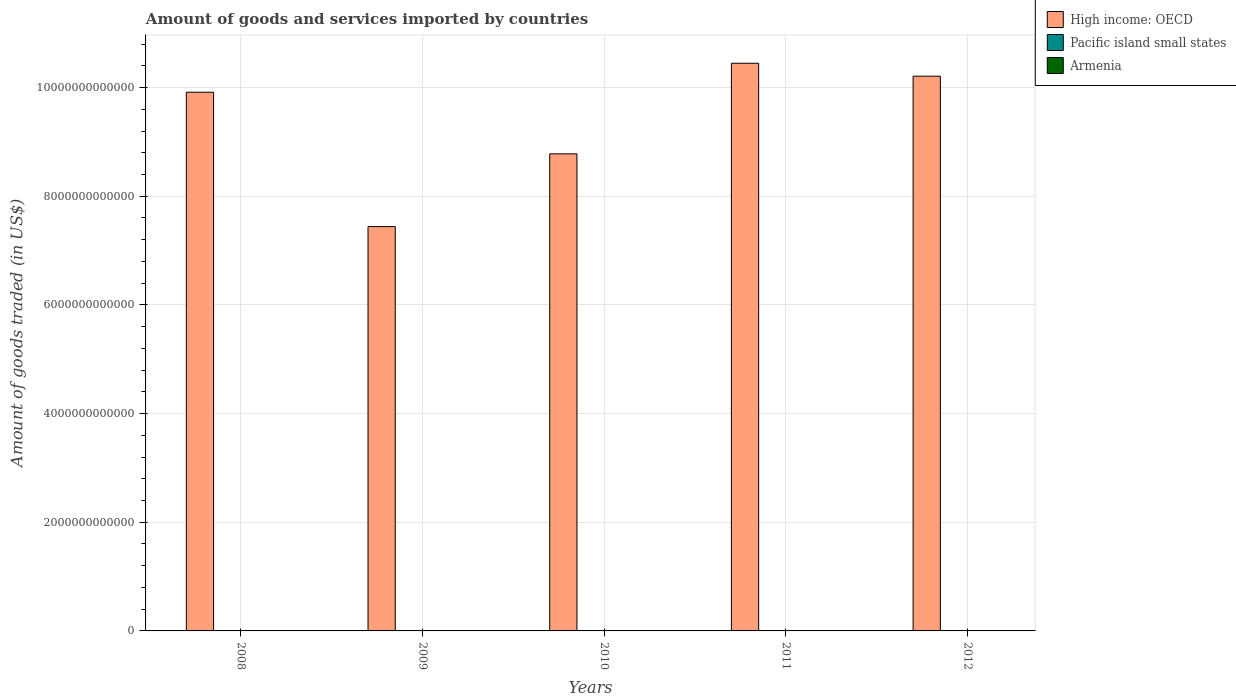Are the number of bars per tick equal to the number of legend labels?
Provide a succinct answer. Yes. How many bars are there on the 4th tick from the left?
Offer a very short reply. 3. How many bars are there on the 2nd tick from the right?
Offer a very short reply. 3. In how many cases, is the number of bars for a given year not equal to the number of legend labels?
Keep it short and to the point. 0. What is the total amount of goods and services imported in Pacific island small states in 2012?
Provide a short and direct response. 3.68e+09. Across all years, what is the maximum total amount of goods and services imported in High income: OECD?
Provide a succinct answer. 1.04e+13. Across all years, what is the minimum total amount of goods and services imported in Pacific island small states?
Ensure brevity in your answer.  2.46e+09. In which year was the total amount of goods and services imported in Armenia maximum?
Provide a succinct answer. 2008. In which year was the total amount of goods and services imported in High income: OECD minimum?
Provide a short and direct response. 2009. What is the total total amount of goods and services imported in High income: OECD in the graph?
Keep it short and to the point. 4.68e+13. What is the difference between the total amount of goods and services imported in Pacific island small states in 2008 and that in 2012?
Give a very brief answer. -1.93e+08. What is the difference between the total amount of goods and services imported in Armenia in 2011 and the total amount of goods and services imported in High income: OECD in 2008?
Your answer should be very brief. -9.91e+12. What is the average total amount of goods and services imported in Pacific island small states per year?
Your answer should be very brief. 3.26e+09. In the year 2011, what is the difference between the total amount of goods and services imported in Pacific island small states and total amount of goods and services imported in High income: OECD?
Offer a terse response. -1.04e+13. What is the ratio of the total amount of goods and services imported in High income: OECD in 2010 to that in 2011?
Your response must be concise. 0.84. What is the difference between the highest and the second highest total amount of goods and services imported in Armenia?
Your answer should be very brief. 2.95e+08. What is the difference between the highest and the lowest total amount of goods and services imported in High income: OECD?
Ensure brevity in your answer.  3.01e+12. In how many years, is the total amount of goods and services imported in Armenia greater than the average total amount of goods and services imported in Armenia taken over all years?
Ensure brevity in your answer.  3. What does the 2nd bar from the left in 2011 represents?
Offer a very short reply. Pacific island small states. What does the 3rd bar from the right in 2008 represents?
Offer a terse response. High income: OECD. How many bars are there?
Offer a very short reply. 15. What is the difference between two consecutive major ticks on the Y-axis?
Offer a very short reply. 2.00e+12. Does the graph contain any zero values?
Provide a short and direct response. No. Does the graph contain grids?
Your answer should be very brief. Yes. How are the legend labels stacked?
Keep it short and to the point. Vertical. What is the title of the graph?
Your answer should be very brief. Amount of goods and services imported by countries. What is the label or title of the Y-axis?
Your answer should be compact. Amount of goods traded (in US$). What is the Amount of goods traded (in US$) in High income: OECD in 2008?
Your answer should be very brief. 9.91e+12. What is the Amount of goods traded (in US$) of Pacific island small states in 2008?
Keep it short and to the point. 3.49e+09. What is the Amount of goods traded (in US$) of Armenia in 2008?
Provide a succinct answer. 3.92e+09. What is the Amount of goods traded (in US$) of High income: OECD in 2009?
Make the answer very short. 7.44e+12. What is the Amount of goods traded (in US$) in Pacific island small states in 2009?
Offer a terse response. 2.46e+09. What is the Amount of goods traded (in US$) of Armenia in 2009?
Provide a short and direct response. 2.86e+09. What is the Amount of goods traded (in US$) in High income: OECD in 2010?
Ensure brevity in your answer.  8.78e+12. What is the Amount of goods traded (in US$) of Pacific island small states in 2010?
Offer a terse response. 3.06e+09. What is the Amount of goods traded (in US$) of Armenia in 2010?
Make the answer very short. 3.26e+09. What is the Amount of goods traded (in US$) of High income: OECD in 2011?
Provide a short and direct response. 1.04e+13. What is the Amount of goods traded (in US$) of Pacific island small states in 2011?
Provide a succinct answer. 3.61e+09. What is the Amount of goods traded (in US$) in Armenia in 2011?
Make the answer very short. 3.54e+09. What is the Amount of goods traded (in US$) in High income: OECD in 2012?
Provide a succinct answer. 1.02e+13. What is the Amount of goods traded (in US$) in Pacific island small states in 2012?
Ensure brevity in your answer.  3.68e+09. What is the Amount of goods traded (in US$) in Armenia in 2012?
Your answer should be compact. 3.63e+09. Across all years, what is the maximum Amount of goods traded (in US$) of High income: OECD?
Provide a succinct answer. 1.04e+13. Across all years, what is the maximum Amount of goods traded (in US$) in Pacific island small states?
Give a very brief answer. 3.68e+09. Across all years, what is the maximum Amount of goods traded (in US$) in Armenia?
Your response must be concise. 3.92e+09. Across all years, what is the minimum Amount of goods traded (in US$) of High income: OECD?
Ensure brevity in your answer.  7.44e+12. Across all years, what is the minimum Amount of goods traded (in US$) of Pacific island small states?
Offer a very short reply. 2.46e+09. Across all years, what is the minimum Amount of goods traded (in US$) of Armenia?
Provide a succinct answer. 2.86e+09. What is the total Amount of goods traded (in US$) in High income: OECD in the graph?
Provide a succinct answer. 4.68e+13. What is the total Amount of goods traded (in US$) in Pacific island small states in the graph?
Keep it short and to the point. 1.63e+1. What is the total Amount of goods traded (in US$) in Armenia in the graph?
Give a very brief answer. 1.72e+1. What is the difference between the Amount of goods traded (in US$) of High income: OECD in 2008 and that in 2009?
Keep it short and to the point. 2.47e+12. What is the difference between the Amount of goods traded (in US$) in Pacific island small states in 2008 and that in 2009?
Give a very brief answer. 1.02e+09. What is the difference between the Amount of goods traded (in US$) of Armenia in 2008 and that in 2009?
Offer a terse response. 1.06e+09. What is the difference between the Amount of goods traded (in US$) of High income: OECD in 2008 and that in 2010?
Your response must be concise. 1.13e+12. What is the difference between the Amount of goods traded (in US$) of Pacific island small states in 2008 and that in 2010?
Offer a very short reply. 4.30e+08. What is the difference between the Amount of goods traded (in US$) of Armenia in 2008 and that in 2010?
Offer a terse response. 6.59e+08. What is the difference between the Amount of goods traded (in US$) of High income: OECD in 2008 and that in 2011?
Give a very brief answer. -5.33e+11. What is the difference between the Amount of goods traded (in US$) of Pacific island small states in 2008 and that in 2011?
Provide a short and direct response. -1.23e+08. What is the difference between the Amount of goods traded (in US$) in Armenia in 2008 and that in 2011?
Your answer should be very brief. 3.81e+08. What is the difference between the Amount of goods traded (in US$) in High income: OECD in 2008 and that in 2012?
Give a very brief answer. -2.95e+11. What is the difference between the Amount of goods traded (in US$) of Pacific island small states in 2008 and that in 2012?
Ensure brevity in your answer.  -1.93e+08. What is the difference between the Amount of goods traded (in US$) of Armenia in 2008 and that in 2012?
Keep it short and to the point. 2.95e+08. What is the difference between the Amount of goods traded (in US$) of High income: OECD in 2009 and that in 2010?
Ensure brevity in your answer.  -1.34e+12. What is the difference between the Amount of goods traded (in US$) of Pacific island small states in 2009 and that in 2010?
Provide a succinct answer. -5.94e+08. What is the difference between the Amount of goods traded (in US$) of Armenia in 2009 and that in 2010?
Your answer should be very brief. -4.00e+08. What is the difference between the Amount of goods traded (in US$) in High income: OECD in 2009 and that in 2011?
Your answer should be very brief. -3.01e+12. What is the difference between the Amount of goods traded (in US$) of Pacific island small states in 2009 and that in 2011?
Offer a very short reply. -1.15e+09. What is the difference between the Amount of goods traded (in US$) of Armenia in 2009 and that in 2011?
Provide a succinct answer. -6.78e+08. What is the difference between the Amount of goods traded (in US$) in High income: OECD in 2009 and that in 2012?
Ensure brevity in your answer.  -2.77e+12. What is the difference between the Amount of goods traded (in US$) in Pacific island small states in 2009 and that in 2012?
Offer a terse response. -1.22e+09. What is the difference between the Amount of goods traded (in US$) of Armenia in 2009 and that in 2012?
Offer a terse response. -7.64e+08. What is the difference between the Amount of goods traded (in US$) of High income: OECD in 2010 and that in 2011?
Your answer should be compact. -1.67e+12. What is the difference between the Amount of goods traded (in US$) of Pacific island small states in 2010 and that in 2011?
Ensure brevity in your answer.  -5.54e+08. What is the difference between the Amount of goods traded (in US$) of Armenia in 2010 and that in 2011?
Provide a short and direct response. -2.78e+08. What is the difference between the Amount of goods traded (in US$) in High income: OECD in 2010 and that in 2012?
Give a very brief answer. -1.43e+12. What is the difference between the Amount of goods traded (in US$) of Pacific island small states in 2010 and that in 2012?
Offer a very short reply. -6.24e+08. What is the difference between the Amount of goods traded (in US$) of Armenia in 2010 and that in 2012?
Give a very brief answer. -3.64e+08. What is the difference between the Amount of goods traded (in US$) in High income: OECD in 2011 and that in 2012?
Provide a succinct answer. 2.38e+11. What is the difference between the Amount of goods traded (in US$) in Pacific island small states in 2011 and that in 2012?
Provide a short and direct response. -6.97e+07. What is the difference between the Amount of goods traded (in US$) in Armenia in 2011 and that in 2012?
Provide a short and direct response. -8.62e+07. What is the difference between the Amount of goods traded (in US$) of High income: OECD in 2008 and the Amount of goods traded (in US$) of Pacific island small states in 2009?
Offer a terse response. 9.91e+12. What is the difference between the Amount of goods traded (in US$) in High income: OECD in 2008 and the Amount of goods traded (in US$) in Armenia in 2009?
Make the answer very short. 9.91e+12. What is the difference between the Amount of goods traded (in US$) of Pacific island small states in 2008 and the Amount of goods traded (in US$) of Armenia in 2009?
Keep it short and to the point. 6.25e+08. What is the difference between the Amount of goods traded (in US$) of High income: OECD in 2008 and the Amount of goods traded (in US$) of Pacific island small states in 2010?
Provide a succinct answer. 9.91e+12. What is the difference between the Amount of goods traded (in US$) in High income: OECD in 2008 and the Amount of goods traded (in US$) in Armenia in 2010?
Ensure brevity in your answer.  9.91e+12. What is the difference between the Amount of goods traded (in US$) in Pacific island small states in 2008 and the Amount of goods traded (in US$) in Armenia in 2010?
Offer a very short reply. 2.26e+08. What is the difference between the Amount of goods traded (in US$) of High income: OECD in 2008 and the Amount of goods traded (in US$) of Pacific island small states in 2011?
Offer a very short reply. 9.91e+12. What is the difference between the Amount of goods traded (in US$) in High income: OECD in 2008 and the Amount of goods traded (in US$) in Armenia in 2011?
Keep it short and to the point. 9.91e+12. What is the difference between the Amount of goods traded (in US$) in Pacific island small states in 2008 and the Amount of goods traded (in US$) in Armenia in 2011?
Your answer should be compact. -5.24e+07. What is the difference between the Amount of goods traded (in US$) of High income: OECD in 2008 and the Amount of goods traded (in US$) of Pacific island small states in 2012?
Provide a succinct answer. 9.91e+12. What is the difference between the Amount of goods traded (in US$) of High income: OECD in 2008 and the Amount of goods traded (in US$) of Armenia in 2012?
Your answer should be compact. 9.91e+12. What is the difference between the Amount of goods traded (in US$) of Pacific island small states in 2008 and the Amount of goods traded (in US$) of Armenia in 2012?
Make the answer very short. -1.39e+08. What is the difference between the Amount of goods traded (in US$) in High income: OECD in 2009 and the Amount of goods traded (in US$) in Pacific island small states in 2010?
Offer a very short reply. 7.44e+12. What is the difference between the Amount of goods traded (in US$) in High income: OECD in 2009 and the Amount of goods traded (in US$) in Armenia in 2010?
Ensure brevity in your answer.  7.44e+12. What is the difference between the Amount of goods traded (in US$) in Pacific island small states in 2009 and the Amount of goods traded (in US$) in Armenia in 2010?
Offer a terse response. -7.99e+08. What is the difference between the Amount of goods traded (in US$) of High income: OECD in 2009 and the Amount of goods traded (in US$) of Pacific island small states in 2011?
Your answer should be compact. 7.44e+12. What is the difference between the Amount of goods traded (in US$) in High income: OECD in 2009 and the Amount of goods traded (in US$) in Armenia in 2011?
Give a very brief answer. 7.44e+12. What is the difference between the Amount of goods traded (in US$) of Pacific island small states in 2009 and the Amount of goods traded (in US$) of Armenia in 2011?
Your answer should be very brief. -1.08e+09. What is the difference between the Amount of goods traded (in US$) in High income: OECD in 2009 and the Amount of goods traded (in US$) in Pacific island small states in 2012?
Make the answer very short. 7.44e+12. What is the difference between the Amount of goods traded (in US$) of High income: OECD in 2009 and the Amount of goods traded (in US$) of Armenia in 2012?
Provide a short and direct response. 7.44e+12. What is the difference between the Amount of goods traded (in US$) in Pacific island small states in 2009 and the Amount of goods traded (in US$) in Armenia in 2012?
Your answer should be compact. -1.16e+09. What is the difference between the Amount of goods traded (in US$) in High income: OECD in 2010 and the Amount of goods traded (in US$) in Pacific island small states in 2011?
Keep it short and to the point. 8.78e+12. What is the difference between the Amount of goods traded (in US$) in High income: OECD in 2010 and the Amount of goods traded (in US$) in Armenia in 2011?
Give a very brief answer. 8.78e+12. What is the difference between the Amount of goods traded (in US$) in Pacific island small states in 2010 and the Amount of goods traded (in US$) in Armenia in 2011?
Provide a short and direct response. -4.83e+08. What is the difference between the Amount of goods traded (in US$) in High income: OECD in 2010 and the Amount of goods traded (in US$) in Pacific island small states in 2012?
Provide a succinct answer. 8.78e+12. What is the difference between the Amount of goods traded (in US$) of High income: OECD in 2010 and the Amount of goods traded (in US$) of Armenia in 2012?
Offer a terse response. 8.78e+12. What is the difference between the Amount of goods traded (in US$) in Pacific island small states in 2010 and the Amount of goods traded (in US$) in Armenia in 2012?
Ensure brevity in your answer.  -5.69e+08. What is the difference between the Amount of goods traded (in US$) of High income: OECD in 2011 and the Amount of goods traded (in US$) of Pacific island small states in 2012?
Give a very brief answer. 1.04e+13. What is the difference between the Amount of goods traded (in US$) of High income: OECD in 2011 and the Amount of goods traded (in US$) of Armenia in 2012?
Provide a succinct answer. 1.04e+13. What is the difference between the Amount of goods traded (in US$) in Pacific island small states in 2011 and the Amount of goods traded (in US$) in Armenia in 2012?
Provide a short and direct response. -1.52e+07. What is the average Amount of goods traded (in US$) of High income: OECD per year?
Give a very brief answer. 9.36e+12. What is the average Amount of goods traded (in US$) of Pacific island small states per year?
Ensure brevity in your answer.  3.26e+09. What is the average Amount of goods traded (in US$) in Armenia per year?
Keep it short and to the point. 3.44e+09. In the year 2008, what is the difference between the Amount of goods traded (in US$) of High income: OECD and Amount of goods traded (in US$) of Pacific island small states?
Ensure brevity in your answer.  9.91e+12. In the year 2008, what is the difference between the Amount of goods traded (in US$) in High income: OECD and Amount of goods traded (in US$) in Armenia?
Offer a terse response. 9.91e+12. In the year 2008, what is the difference between the Amount of goods traded (in US$) in Pacific island small states and Amount of goods traded (in US$) in Armenia?
Your answer should be very brief. -4.34e+08. In the year 2009, what is the difference between the Amount of goods traded (in US$) in High income: OECD and Amount of goods traded (in US$) in Pacific island small states?
Your answer should be compact. 7.44e+12. In the year 2009, what is the difference between the Amount of goods traded (in US$) of High income: OECD and Amount of goods traded (in US$) of Armenia?
Your answer should be very brief. 7.44e+12. In the year 2009, what is the difference between the Amount of goods traded (in US$) of Pacific island small states and Amount of goods traded (in US$) of Armenia?
Offer a terse response. -3.99e+08. In the year 2010, what is the difference between the Amount of goods traded (in US$) of High income: OECD and Amount of goods traded (in US$) of Pacific island small states?
Offer a terse response. 8.78e+12. In the year 2010, what is the difference between the Amount of goods traded (in US$) in High income: OECD and Amount of goods traded (in US$) in Armenia?
Provide a succinct answer. 8.78e+12. In the year 2010, what is the difference between the Amount of goods traded (in US$) of Pacific island small states and Amount of goods traded (in US$) of Armenia?
Provide a succinct answer. -2.05e+08. In the year 2011, what is the difference between the Amount of goods traded (in US$) in High income: OECD and Amount of goods traded (in US$) in Pacific island small states?
Provide a short and direct response. 1.04e+13. In the year 2011, what is the difference between the Amount of goods traded (in US$) of High income: OECD and Amount of goods traded (in US$) of Armenia?
Provide a succinct answer. 1.04e+13. In the year 2011, what is the difference between the Amount of goods traded (in US$) of Pacific island small states and Amount of goods traded (in US$) of Armenia?
Offer a terse response. 7.10e+07. In the year 2012, what is the difference between the Amount of goods traded (in US$) of High income: OECD and Amount of goods traded (in US$) of Pacific island small states?
Your response must be concise. 1.02e+13. In the year 2012, what is the difference between the Amount of goods traded (in US$) of High income: OECD and Amount of goods traded (in US$) of Armenia?
Your answer should be very brief. 1.02e+13. In the year 2012, what is the difference between the Amount of goods traded (in US$) of Pacific island small states and Amount of goods traded (in US$) of Armenia?
Offer a terse response. 5.44e+07. What is the ratio of the Amount of goods traded (in US$) in High income: OECD in 2008 to that in 2009?
Provide a succinct answer. 1.33. What is the ratio of the Amount of goods traded (in US$) in Pacific island small states in 2008 to that in 2009?
Make the answer very short. 1.42. What is the ratio of the Amount of goods traded (in US$) in Armenia in 2008 to that in 2009?
Make the answer very short. 1.37. What is the ratio of the Amount of goods traded (in US$) of High income: OECD in 2008 to that in 2010?
Your response must be concise. 1.13. What is the ratio of the Amount of goods traded (in US$) in Pacific island small states in 2008 to that in 2010?
Provide a short and direct response. 1.14. What is the ratio of the Amount of goods traded (in US$) in Armenia in 2008 to that in 2010?
Keep it short and to the point. 1.2. What is the ratio of the Amount of goods traded (in US$) in High income: OECD in 2008 to that in 2011?
Your answer should be compact. 0.95. What is the ratio of the Amount of goods traded (in US$) in Pacific island small states in 2008 to that in 2011?
Your response must be concise. 0.97. What is the ratio of the Amount of goods traded (in US$) in Armenia in 2008 to that in 2011?
Provide a short and direct response. 1.11. What is the ratio of the Amount of goods traded (in US$) in High income: OECD in 2008 to that in 2012?
Offer a very short reply. 0.97. What is the ratio of the Amount of goods traded (in US$) of Pacific island small states in 2008 to that in 2012?
Offer a terse response. 0.95. What is the ratio of the Amount of goods traded (in US$) in Armenia in 2008 to that in 2012?
Keep it short and to the point. 1.08. What is the ratio of the Amount of goods traded (in US$) in High income: OECD in 2009 to that in 2010?
Provide a succinct answer. 0.85. What is the ratio of the Amount of goods traded (in US$) of Pacific island small states in 2009 to that in 2010?
Provide a succinct answer. 0.81. What is the ratio of the Amount of goods traded (in US$) of Armenia in 2009 to that in 2010?
Provide a short and direct response. 0.88. What is the ratio of the Amount of goods traded (in US$) in High income: OECD in 2009 to that in 2011?
Provide a short and direct response. 0.71. What is the ratio of the Amount of goods traded (in US$) in Pacific island small states in 2009 to that in 2011?
Give a very brief answer. 0.68. What is the ratio of the Amount of goods traded (in US$) of Armenia in 2009 to that in 2011?
Your answer should be compact. 0.81. What is the ratio of the Amount of goods traded (in US$) in High income: OECD in 2009 to that in 2012?
Your answer should be compact. 0.73. What is the ratio of the Amount of goods traded (in US$) in Pacific island small states in 2009 to that in 2012?
Keep it short and to the point. 0.67. What is the ratio of the Amount of goods traded (in US$) in Armenia in 2009 to that in 2012?
Offer a very short reply. 0.79. What is the ratio of the Amount of goods traded (in US$) of High income: OECD in 2010 to that in 2011?
Give a very brief answer. 0.84. What is the ratio of the Amount of goods traded (in US$) of Pacific island small states in 2010 to that in 2011?
Give a very brief answer. 0.85. What is the ratio of the Amount of goods traded (in US$) in Armenia in 2010 to that in 2011?
Provide a short and direct response. 0.92. What is the ratio of the Amount of goods traded (in US$) in High income: OECD in 2010 to that in 2012?
Give a very brief answer. 0.86. What is the ratio of the Amount of goods traded (in US$) in Pacific island small states in 2010 to that in 2012?
Ensure brevity in your answer.  0.83. What is the ratio of the Amount of goods traded (in US$) in Armenia in 2010 to that in 2012?
Provide a succinct answer. 0.9. What is the ratio of the Amount of goods traded (in US$) in High income: OECD in 2011 to that in 2012?
Give a very brief answer. 1.02. What is the ratio of the Amount of goods traded (in US$) in Pacific island small states in 2011 to that in 2012?
Give a very brief answer. 0.98. What is the ratio of the Amount of goods traded (in US$) in Armenia in 2011 to that in 2012?
Provide a short and direct response. 0.98. What is the difference between the highest and the second highest Amount of goods traded (in US$) in High income: OECD?
Make the answer very short. 2.38e+11. What is the difference between the highest and the second highest Amount of goods traded (in US$) of Pacific island small states?
Offer a very short reply. 6.97e+07. What is the difference between the highest and the second highest Amount of goods traded (in US$) in Armenia?
Offer a terse response. 2.95e+08. What is the difference between the highest and the lowest Amount of goods traded (in US$) in High income: OECD?
Your answer should be compact. 3.01e+12. What is the difference between the highest and the lowest Amount of goods traded (in US$) in Pacific island small states?
Offer a very short reply. 1.22e+09. What is the difference between the highest and the lowest Amount of goods traded (in US$) in Armenia?
Your response must be concise. 1.06e+09. 